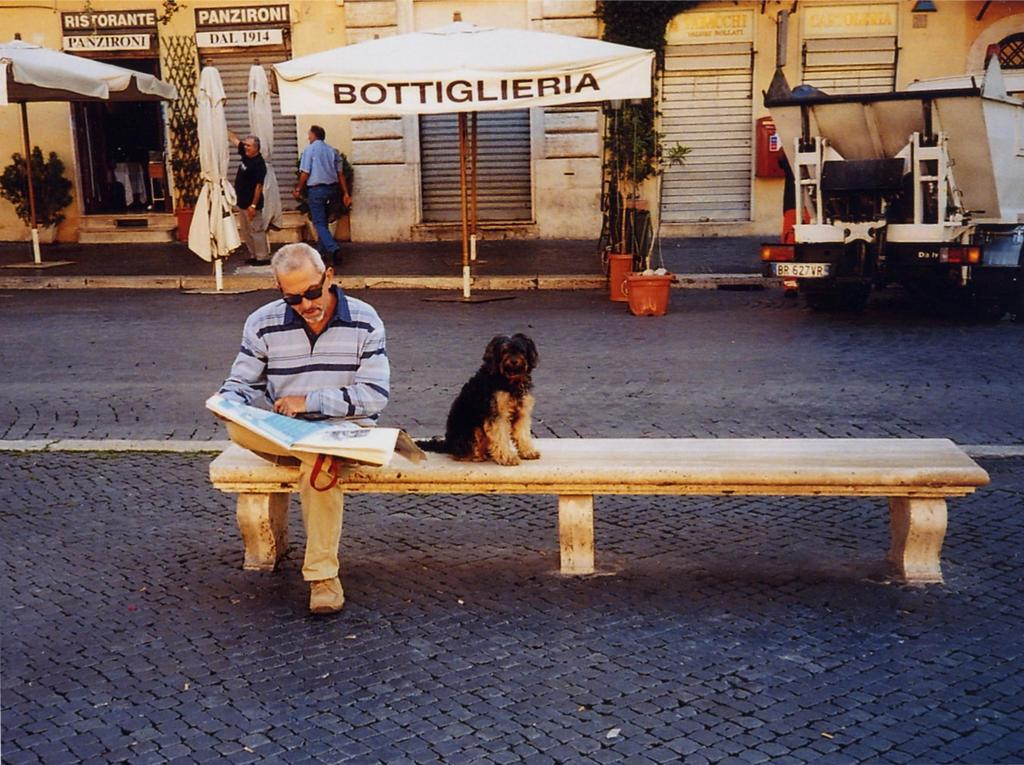What is the man in the image doing? The man is sitting on a bench and reading a newspaper. Is there any other living creature in the image? Yes, there is a dog beside the man. What can be seen in the background of the image? There are two men standing in the background, and they are on a footpath. What type of bell can be heard ringing in the image? There is no bell present or ringing in the image. What is the dog using to knit a sweater in the image? The dog is not knitting a sweater or using any yarn in the image. 